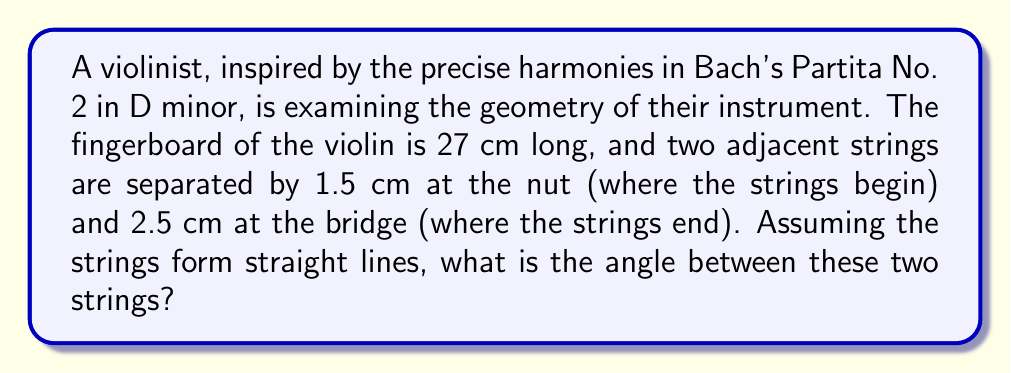Could you help me with this problem? Let's approach this step-by-step:

1) We can view this problem as a trapezoid, where:
   - The parallel sides are the distances between the strings at the nut and bridge
   - The non-parallel sides are the strings themselves

2) Let's define our variables:
   $a = 1.5$ cm (distance at the nut)
   $b = 2.5$ cm (distance at the bridge)
   $h = 27$ cm (length of the fingerboard)

3) The angle we're looking for is the angle between the non-parallel sides of this trapezoid. We can find this by calculating the difference in the lengths of the parallel sides and using trigonometry.

4) The difference in length between the parallel sides is:
   $b - a = 2.5 - 1.5 = 1$ cm

5) We can split this trapezoid into a rectangle and a triangle. The triangle's base is the 1 cm difference we just calculated, and its height is the 27 cm length of the fingerboard.

6) Now we can use the arctangent function to find the angle. The tangent of the angle is the opposite (1 cm) over the adjacent (27 cm):

   $$\tan(\theta) = \frac{1}{27}$$

7) Therefore, the angle is:

   $$\theta = \arctan(\frac{1}{27})$$

8) Using a calculator or computer, we can evaluate this:

   $$\theta \approx 2.12 \text{ degrees}$$

[asy]
import geometry;

size(200);

pair A = (0,0), B = (27,0), C = (27,2.5), D = (0,1.5);
draw(A--B--C--D--cycle);
draw(D--C,dashed);

label("27 cm", (13.5,-1), S);
label("1.5 cm", (-1,0.75), W);
label("2.5 cm", (28,1.25), E);
label("$\theta$", (0.5,0.2), NW);

dot("A", A, SW);
dot("B", B, SE);
dot("C", C, NE);
dot("D", D, NW);
[/asy]
Answer: $2.12^\circ$ 